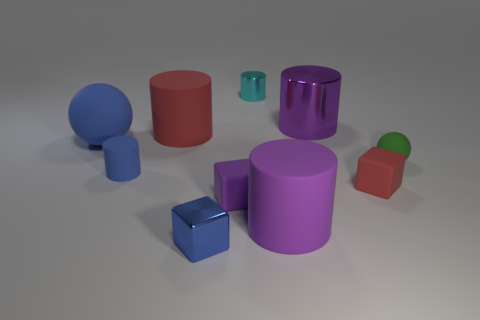If this composition were part of a larger story, what role do you think these objects could play? If we imagine these objects as part of a narrative, they could represent characters or elements within a fantastical or abstract setting. The varying sizes and colors might symbolize different personalities or powers. In a more practical context, they could be tools or parts of a puzzle, each serving a specific function within the story, perhaps leading to a goal or resolution. 